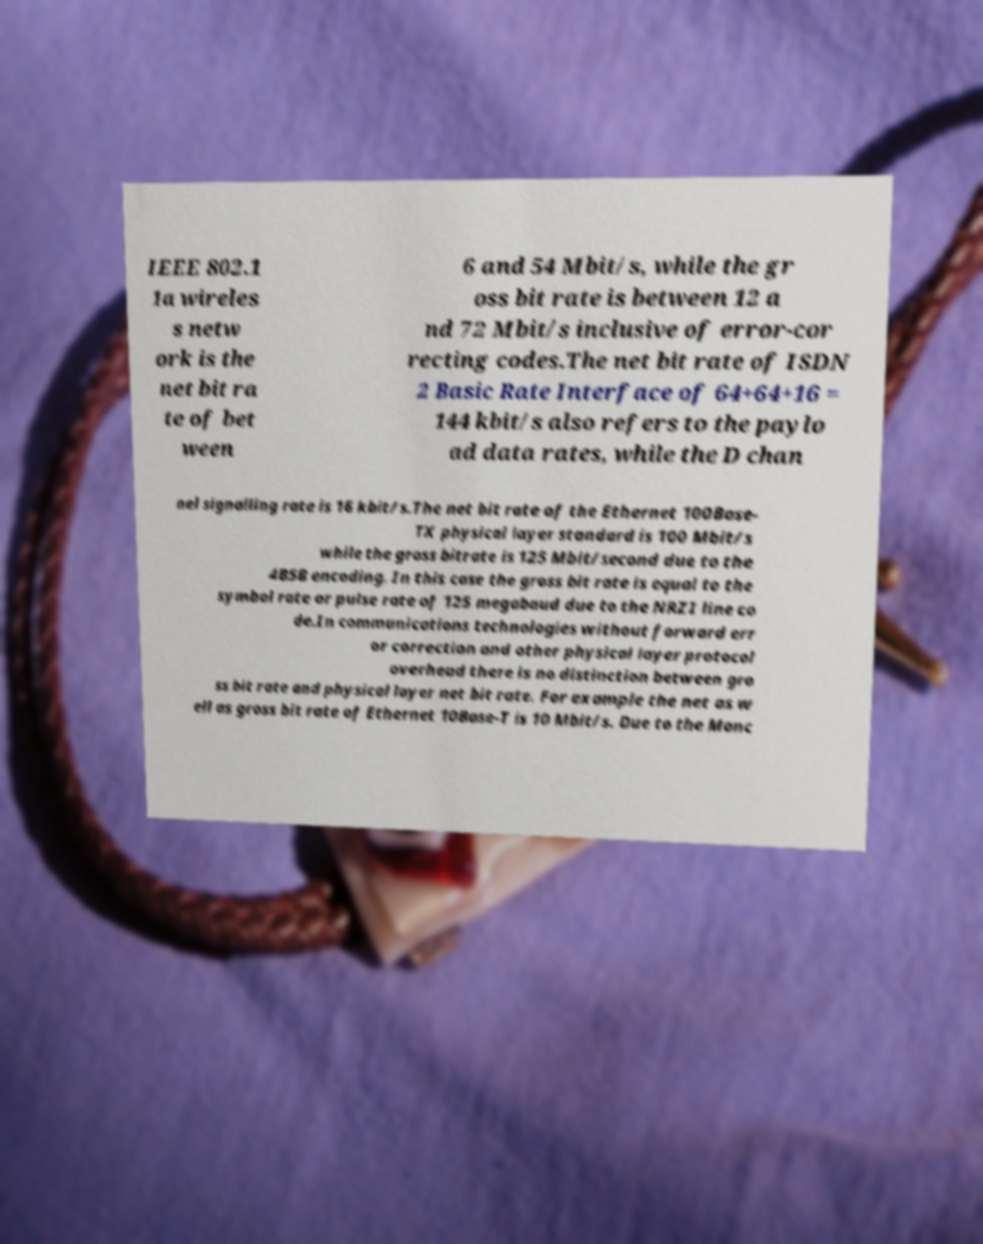There's text embedded in this image that I need extracted. Can you transcribe it verbatim? IEEE 802.1 1a wireles s netw ork is the net bit ra te of bet ween 6 and 54 Mbit/s, while the gr oss bit rate is between 12 a nd 72 Mbit/s inclusive of error-cor recting codes.The net bit rate of ISDN 2 Basic Rate Interface of 64+64+16 = 144 kbit/s also refers to the paylo ad data rates, while the D chan nel signalling rate is 16 kbit/s.The net bit rate of the Ethernet 100Base- TX physical layer standard is 100 Mbit/s while the gross bitrate is 125 Mbit/second due to the 4B5B encoding. In this case the gross bit rate is equal to the symbol rate or pulse rate of 125 megabaud due to the NRZI line co de.In communications technologies without forward err or correction and other physical layer protocol overhead there is no distinction between gro ss bit rate and physical layer net bit rate. For example the net as w ell as gross bit rate of Ethernet 10Base-T is 10 Mbit/s. Due to the Manc 